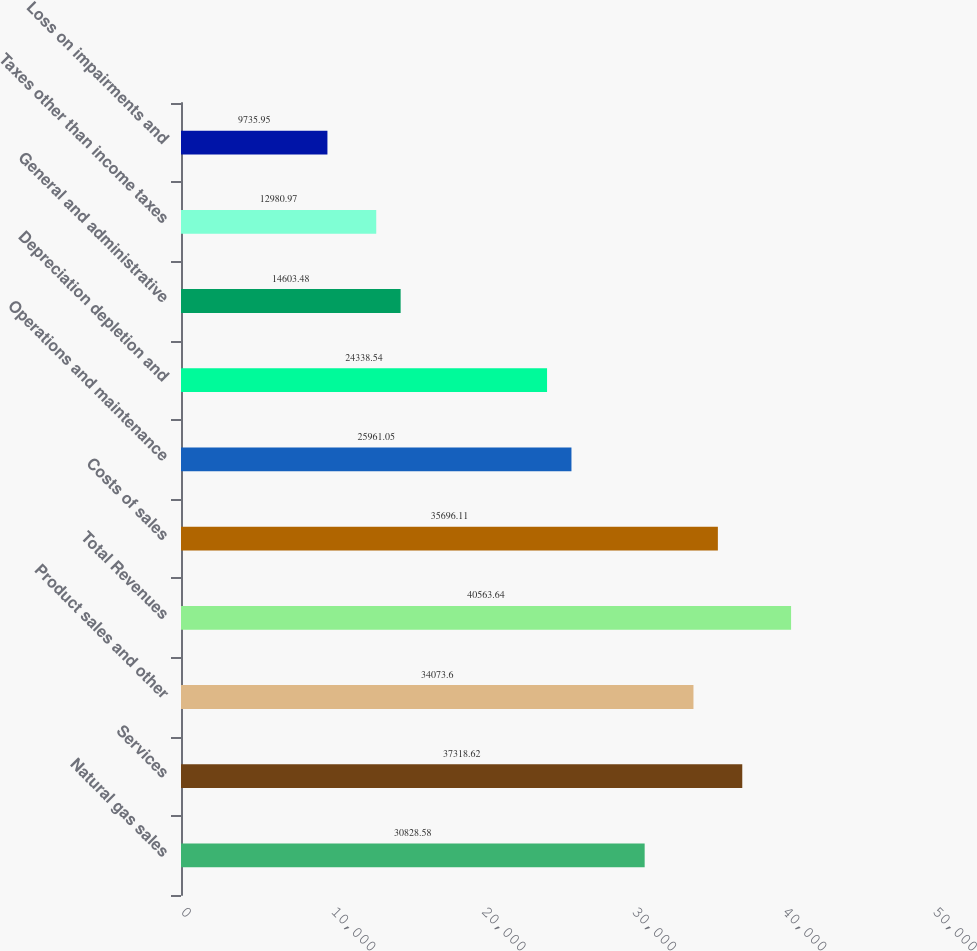<chart> <loc_0><loc_0><loc_500><loc_500><bar_chart><fcel>Natural gas sales<fcel>Services<fcel>Product sales and other<fcel>Total Revenues<fcel>Costs of sales<fcel>Operations and maintenance<fcel>Depreciation depletion and<fcel>General and administrative<fcel>Taxes other than income taxes<fcel>Loss on impairments and<nl><fcel>30828.6<fcel>37318.6<fcel>34073.6<fcel>40563.6<fcel>35696.1<fcel>25961<fcel>24338.5<fcel>14603.5<fcel>12981<fcel>9735.95<nl></chart> 